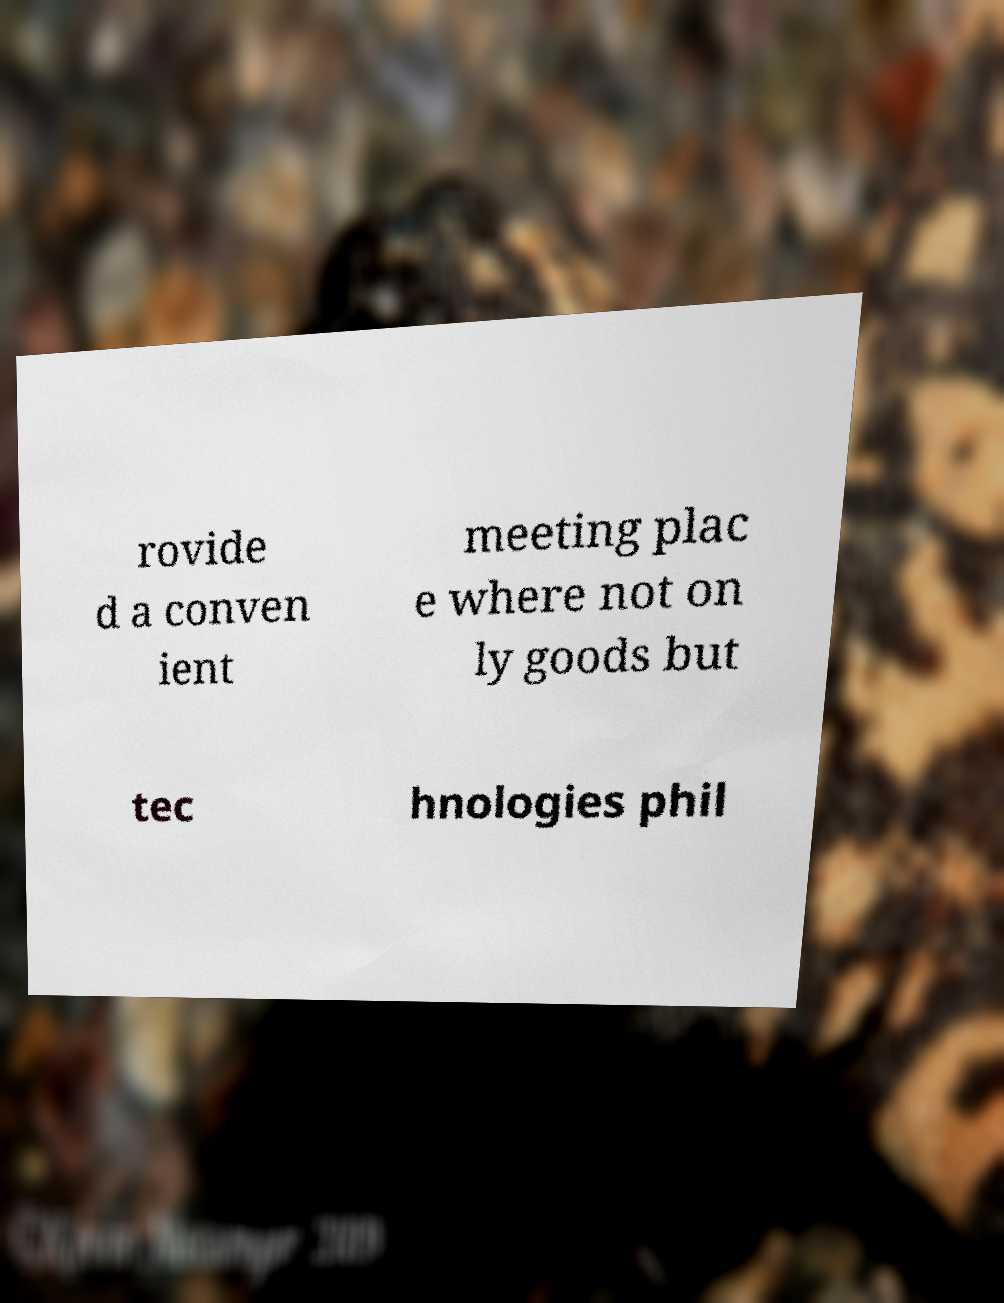Can you accurately transcribe the text from the provided image for me? rovide d a conven ient meeting plac e where not on ly goods but tec hnologies phil 